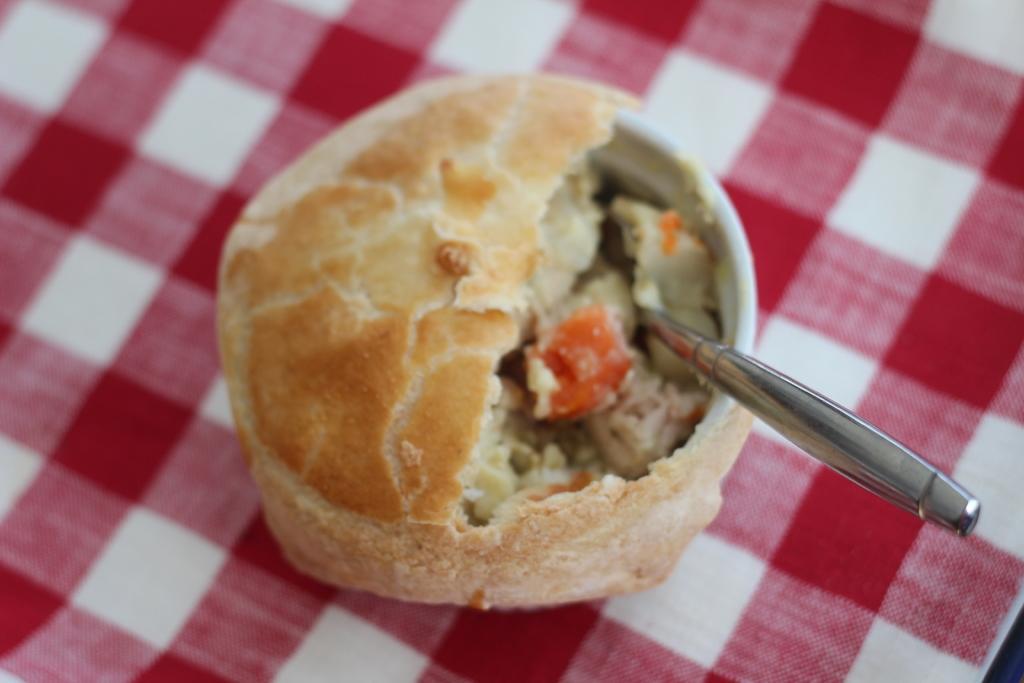In one or two sentences, can you explain what this image depicts? In this picture there is food in the bowl and there is a spoon. At the bottom there is a red and white check cloth. 